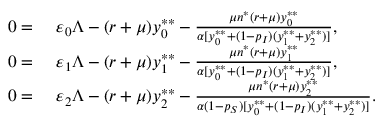Convert formula to latex. <formula><loc_0><loc_0><loc_500><loc_500>\begin{array} { r l } { 0 = } & { \varepsilon _ { 0 } \Lambda - ( r + \mu ) y _ { 0 } ^ { * * } - \frac { \mu n ^ { * } ( r + \mu ) y _ { 0 } ^ { * * } } { \alpha [ y _ { 0 } ^ { * * } + ( 1 - p _ { I } ) ( y _ { 1 } ^ { * * } + y _ { 2 } ^ { * * } ) ] } , } \\ { 0 = } & { \varepsilon _ { 1 } \Lambda - ( r + \mu ) y _ { 1 } ^ { * * } - \frac { \mu n ^ { * } ( r + \mu ) y _ { 1 } ^ { * * } } { \alpha [ y _ { 0 } ^ { * * } + ( 1 - p _ { I } ) ( y _ { 1 } ^ { * * } + y _ { 2 } ^ { * * } ) ] } , } \\ { 0 = } & { \varepsilon _ { 2 } \Lambda - ( r + \mu ) y _ { 2 } ^ { * * } - \frac { \mu n ^ { * } ( r + \mu ) y _ { 2 } ^ { * * } } { \alpha ( 1 - p _ { S } ) [ y _ { 0 } ^ { * * } + ( 1 - p _ { I } ) ( y _ { 1 } ^ { * * } + y _ { 2 } ^ { * * } ) ] } . } \end{array}</formula> 